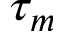<formula> <loc_0><loc_0><loc_500><loc_500>\tau _ { m }</formula> 